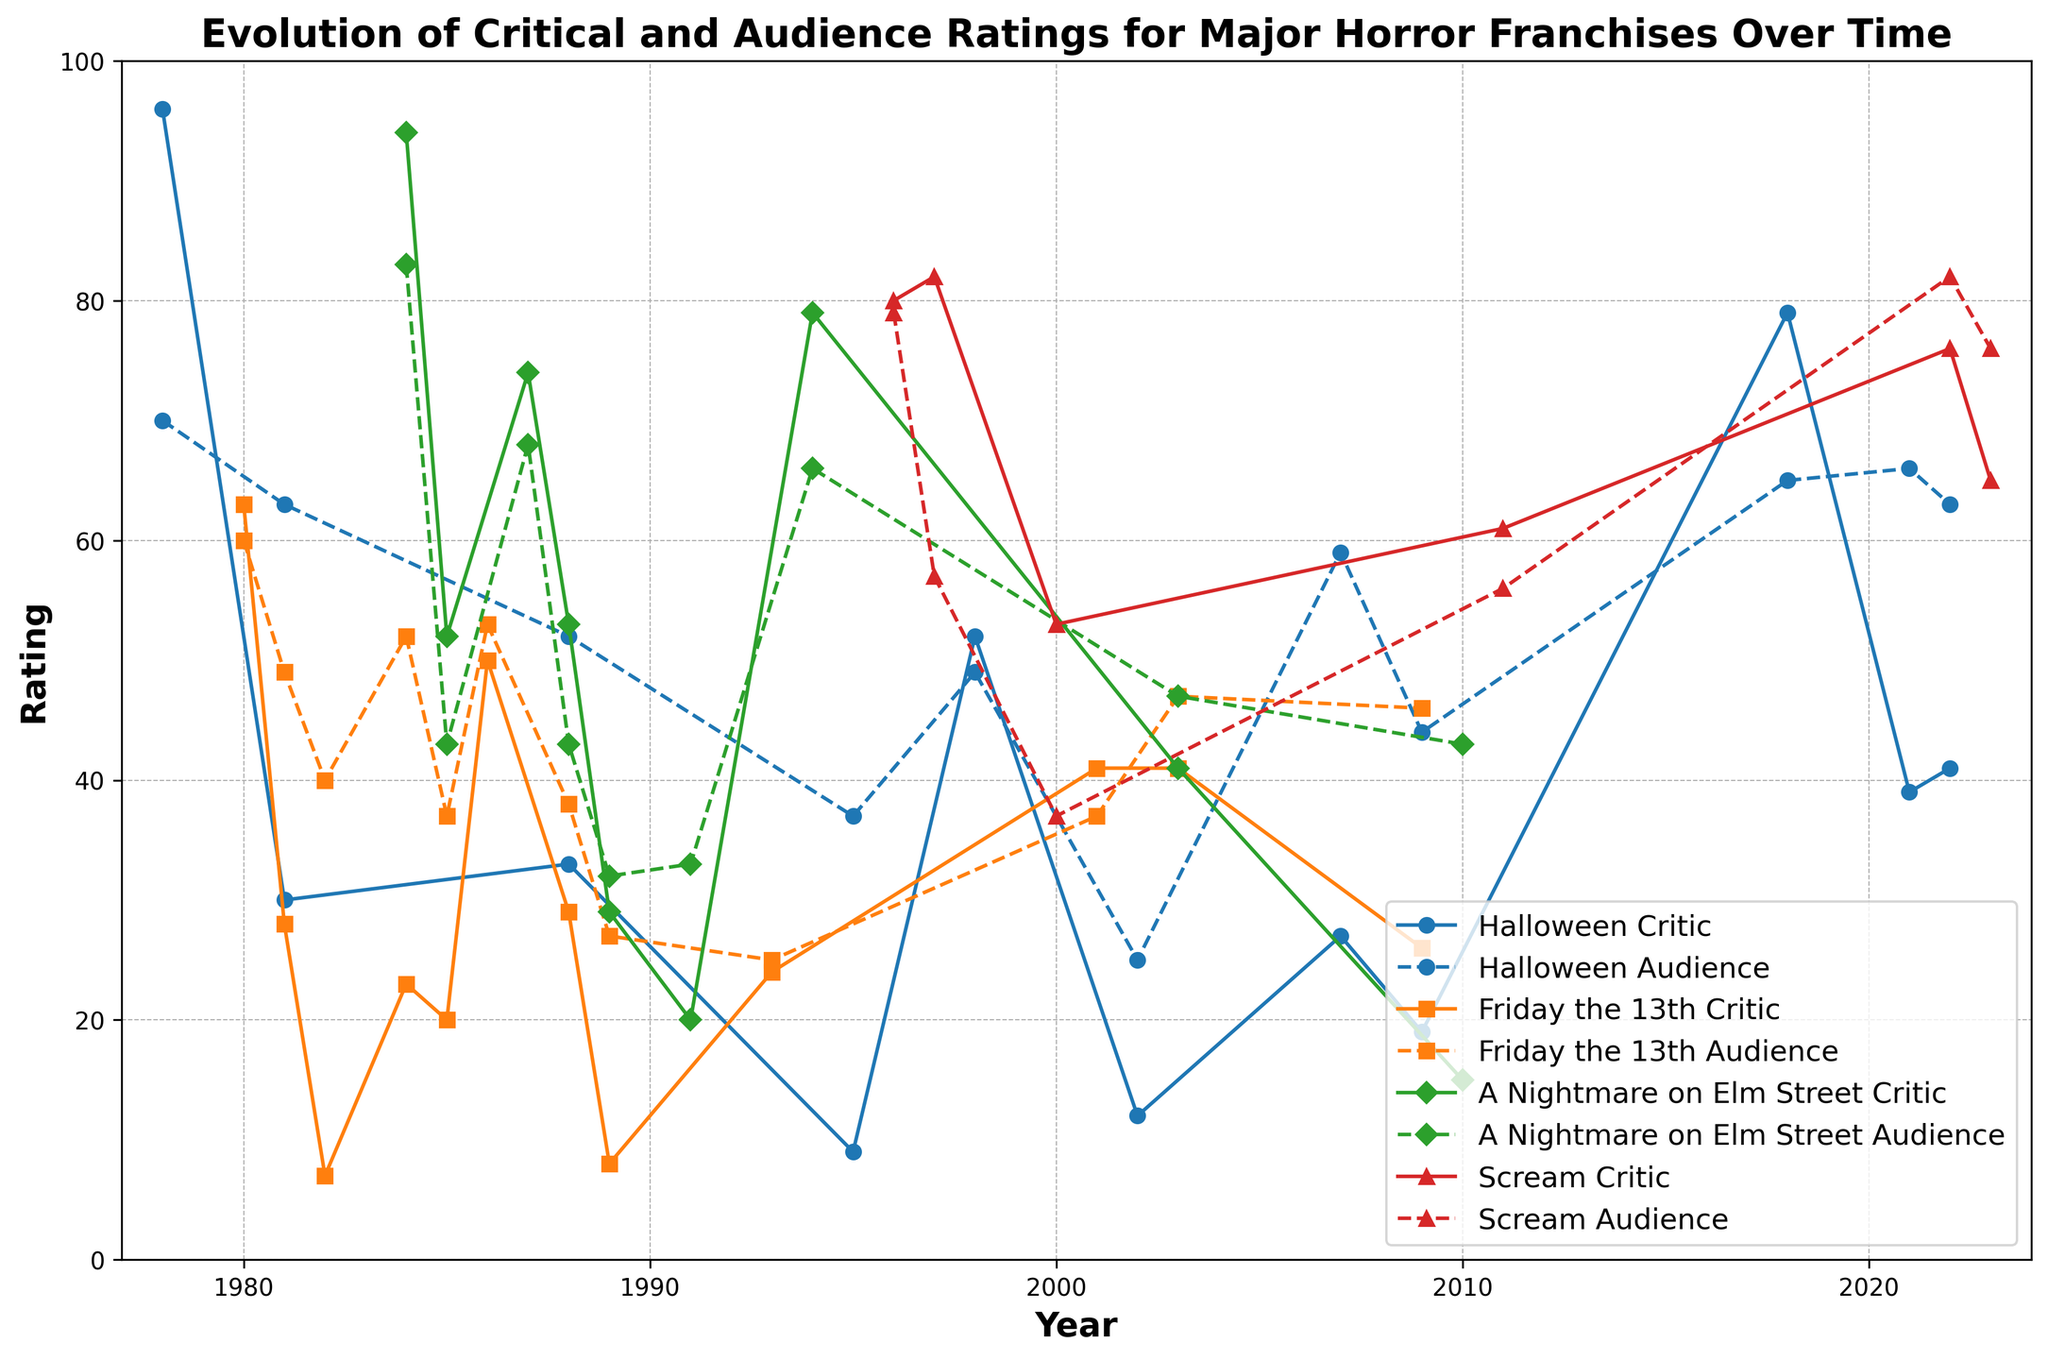Which franchise had the highest critic rating in its first film? The highest critic rating for an initial film can be found by looking at the critic ratings for the first film in each franchise and identifying the highest value. "Halloween" (96 in 1978), "Friday the 13th" (63 in 1980), "A Nightmare on Elm Street" (94 in 1984), and "Scream" (80 in 1996). "Halloween" has the highest initial critic rating.
Answer: Halloween Which franchise shows the largest difference between critic and audience ratings in any single year? To identify this, scan each year's critic and audience ratings for each franchise and find the year with the largest absolute difference. For instance, in "Halloween" 1995, the critic rating is 9 and the audience rating is 37, making the difference 28. Compare across all franchises and years.
Answer: Halloween in 1995 Which year saw the highest audience rating for the "Scream" franchise? To determine this, check the audience ratings for the years "Scream" movies were released. Observing the audience ratings for 1996 (79), 1997 (57), 2000 (37), 2011 (56), 2022 (82), and 2023 (76), the highest audience rating occurred in 2022.
Answer: 2022 How do the critic ratings for "Halloween" in 2018 and 2021 compare? Comparing the critic ratings of "Halloween" in 2018 (79) and 2021 (39) shows a significant decrease.
Answer: Lower in 2021 Which two franchises had critic ratings of exactly 41 in any of their films? Scan the list for the critic ratings and identify the two franchises with a critic rating of 41. This appears for both "Friday the 13th" (2001 and 2003) and "A Nightmare on Elm Street" (2003).
Answer: Friday the 13th and A Nightmare on Elm Street What is the most frequent type of rating (critic or audience) between 50 and 60 for "Friday the 13th"? Analyze the data for both critic and audience ratings within the 50-60 range for "Friday the 13th" across different years: critic ratings of 50 (1986) and audience ratings of 52 (1984) and 53 (1986). The critic rating appears once and audience ratings twice.
Answer: Audience Which franchise experienced the steepest decline in critic ratings between two consecutive films? Compare the drop in critic ratings between consecutive films for each franchise. For example, "Friday the 13th" dropped from 63 in 1980 to 28 in 1981 (a difference of 35 points). Analyze other franchises for similar steep drops.
Answer: Friday the 13th In which year did "A Nightmare on Elm Street" have its lowest audience rating? Look at the audience ratings for "A Nightmare on Elm Street" in each year: 1984 (83), 1985 (43), 1987 (68), 1988 (43), 1989 (32), 1991 (33), 1994 (66), 2003 (47), and 2010 (43). The lowest rating occurred in 1989.
Answer: 1989 